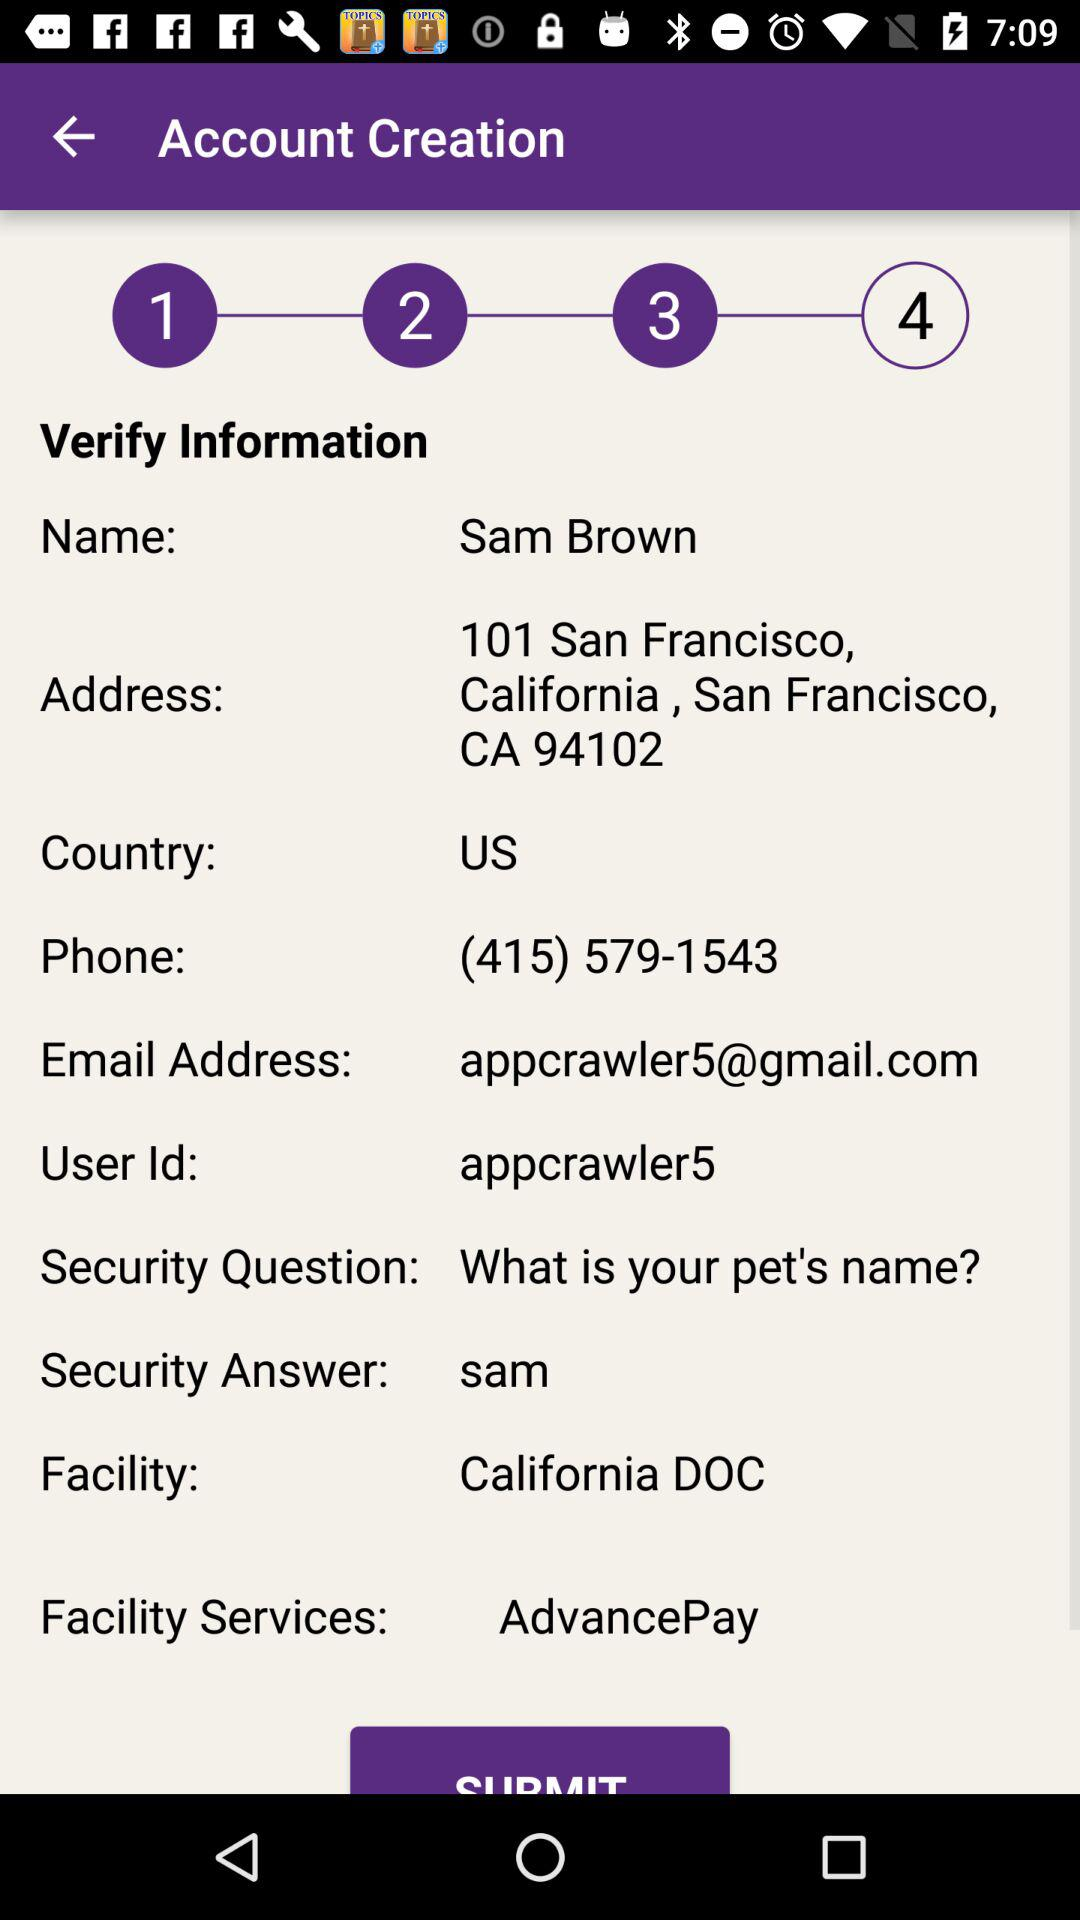What is the address of Sam Brown? The address of Sam Brown is 101 San Francisco, California, San Francisco, CA 94102. 